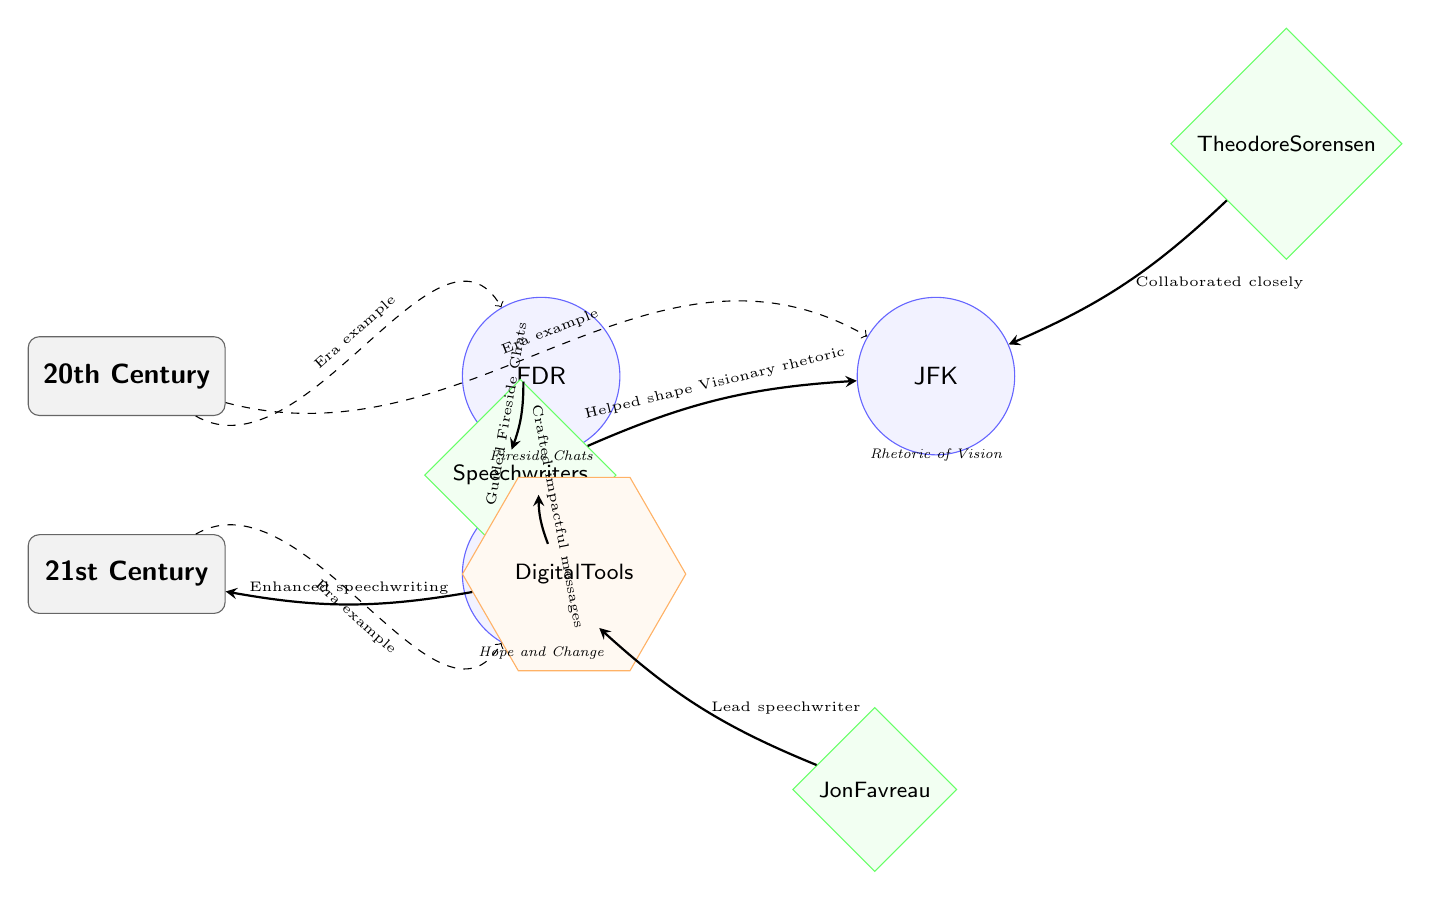What presidents are included in the diagram? The diagram features three presidents: FDR, JFK, and Obama. These names are clearly labeled within the circles representing each president.
Answer: FDR, JFK, Obama How many writing teams are represented in the 20th Century? There is one writing team labeled as "Speechwriters," which is placed centrally and connects to both FDR and JFK.
Answer: 1 What did Theodore Sorensen do for JFK? Theo Sorensen is indicated as having "Collaborated closely" with JFK, as per the directed connection labeled with this text.
Answer: Collaborated closely What major tools are highlighted for the 21st Century? The diagram identifies "Digital Tools" as a major resource in the 21st Century, noted in the lower right corner.
Answer: Digital Tools Which president's speechwriters helped shape visionary rhetoric? The speechwriters influenced JFK's communication style, as labeled in the connection to JFK with this specific description.
Answer: JFK What type of diagram is depicted here? The diagram represents the relationships and evolution of speechwriting teams and their connection to U.S. presidents over time. This type of diagram categorically falls under a flowchart or infographic style used to summarize complex information visually.
Answer: Infographic What is a notable message crafted for Obama? The description beside Obama states his speeches were centered around "Hope and Change," indicating the primary theme of his messaging.
Answer: Hope and Change Which century marks the shift from traditional to digital tools? The progression from the "20th Century" node to the "21st Century" node indicates that this change occurred as we moved into the 21st Century, where digital tools became prevalent.
Answer: 21st Century What is the relationship between speechwriters and Obama's messaging? The diagram shows the connection stating that speechwriters "Crafted impactful messages" for Obama, indicating their direct influence on his communication.
Answer: Crafted impactful messages 